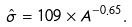<formula> <loc_0><loc_0><loc_500><loc_500>\hat { \sigma } = 1 0 9 \times A ^ { - 0 . 6 5 } .</formula> 